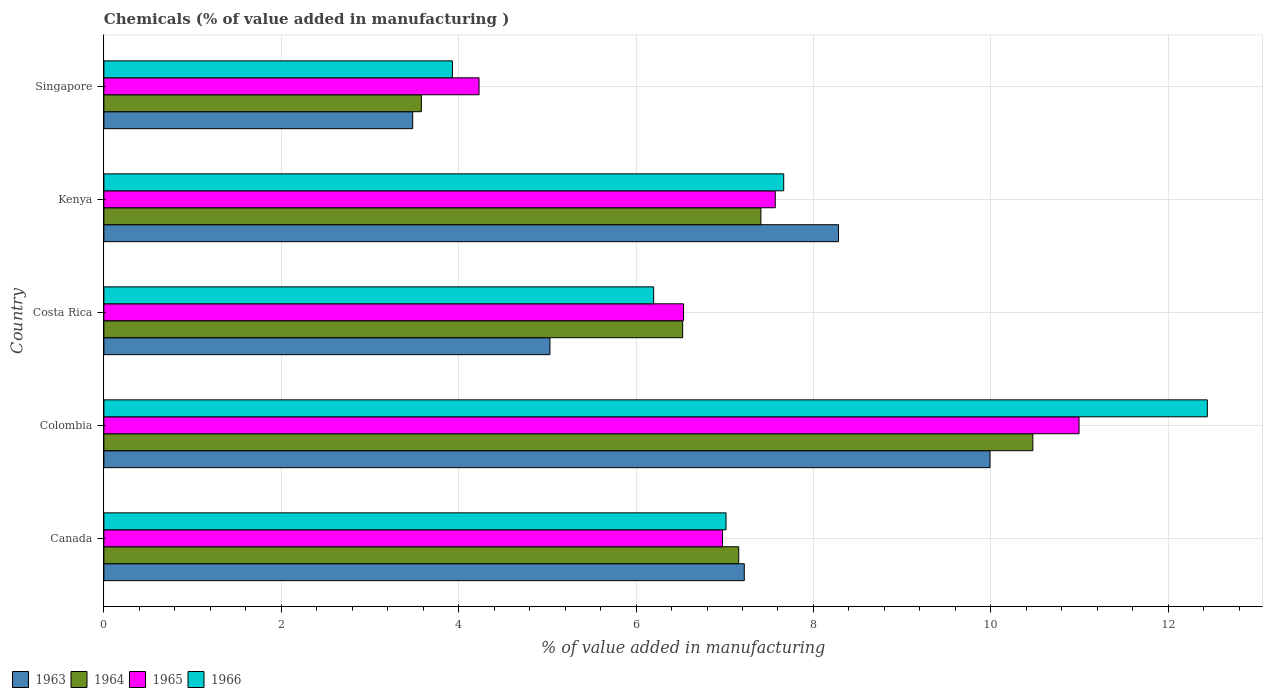How many different coloured bars are there?
Provide a succinct answer. 4. How many groups of bars are there?
Provide a succinct answer. 5. How many bars are there on the 1st tick from the top?
Make the answer very short. 4. How many bars are there on the 3rd tick from the bottom?
Provide a short and direct response. 4. What is the label of the 4th group of bars from the top?
Your answer should be very brief. Colombia. What is the value added in manufacturing chemicals in 1964 in Kenya?
Ensure brevity in your answer.  7.41. Across all countries, what is the maximum value added in manufacturing chemicals in 1965?
Your answer should be very brief. 10.99. Across all countries, what is the minimum value added in manufacturing chemicals in 1964?
Offer a terse response. 3.58. In which country was the value added in manufacturing chemicals in 1966 maximum?
Your answer should be very brief. Colombia. In which country was the value added in manufacturing chemicals in 1964 minimum?
Your answer should be very brief. Singapore. What is the total value added in manufacturing chemicals in 1966 in the graph?
Offer a terse response. 37.25. What is the difference between the value added in manufacturing chemicals in 1965 in Colombia and that in Costa Rica?
Ensure brevity in your answer.  4.46. What is the difference between the value added in manufacturing chemicals in 1965 in Costa Rica and the value added in manufacturing chemicals in 1966 in Singapore?
Provide a succinct answer. 2.61. What is the average value added in manufacturing chemicals in 1964 per country?
Make the answer very short. 7.03. What is the difference between the value added in manufacturing chemicals in 1965 and value added in manufacturing chemicals in 1966 in Kenya?
Offer a very short reply. -0.1. What is the ratio of the value added in manufacturing chemicals in 1966 in Colombia to that in Singapore?
Give a very brief answer. 3.17. What is the difference between the highest and the second highest value added in manufacturing chemicals in 1963?
Offer a very short reply. 1.71. What is the difference between the highest and the lowest value added in manufacturing chemicals in 1963?
Ensure brevity in your answer.  6.51. Is the sum of the value added in manufacturing chemicals in 1964 in Colombia and Singapore greater than the maximum value added in manufacturing chemicals in 1966 across all countries?
Your response must be concise. Yes. What does the 3rd bar from the top in Colombia represents?
Give a very brief answer. 1964. What does the 4th bar from the bottom in Colombia represents?
Provide a short and direct response. 1966. Is it the case that in every country, the sum of the value added in manufacturing chemicals in 1965 and value added in manufacturing chemicals in 1963 is greater than the value added in manufacturing chemicals in 1964?
Your answer should be compact. Yes. What is the difference between two consecutive major ticks on the X-axis?
Ensure brevity in your answer.  2. Are the values on the major ticks of X-axis written in scientific E-notation?
Your answer should be very brief. No. Does the graph contain grids?
Offer a very short reply. Yes. Where does the legend appear in the graph?
Give a very brief answer. Bottom left. How are the legend labels stacked?
Make the answer very short. Horizontal. What is the title of the graph?
Provide a short and direct response. Chemicals (% of value added in manufacturing ). What is the label or title of the X-axis?
Offer a very short reply. % of value added in manufacturing. What is the label or title of the Y-axis?
Offer a very short reply. Country. What is the % of value added in manufacturing of 1963 in Canada?
Provide a short and direct response. 7.22. What is the % of value added in manufacturing in 1964 in Canada?
Keep it short and to the point. 7.16. What is the % of value added in manufacturing in 1965 in Canada?
Offer a terse response. 6.98. What is the % of value added in manufacturing in 1966 in Canada?
Ensure brevity in your answer.  7.01. What is the % of value added in manufacturing in 1963 in Colombia?
Provide a short and direct response. 9.99. What is the % of value added in manufacturing of 1964 in Colombia?
Provide a succinct answer. 10.47. What is the % of value added in manufacturing in 1965 in Colombia?
Offer a terse response. 10.99. What is the % of value added in manufacturing of 1966 in Colombia?
Your answer should be compact. 12.44. What is the % of value added in manufacturing of 1963 in Costa Rica?
Keep it short and to the point. 5.03. What is the % of value added in manufacturing of 1964 in Costa Rica?
Make the answer very short. 6.53. What is the % of value added in manufacturing of 1965 in Costa Rica?
Offer a terse response. 6.54. What is the % of value added in manufacturing of 1966 in Costa Rica?
Ensure brevity in your answer.  6.2. What is the % of value added in manufacturing of 1963 in Kenya?
Your answer should be compact. 8.28. What is the % of value added in manufacturing in 1964 in Kenya?
Provide a succinct answer. 7.41. What is the % of value added in manufacturing in 1965 in Kenya?
Your answer should be compact. 7.57. What is the % of value added in manufacturing in 1966 in Kenya?
Provide a succinct answer. 7.67. What is the % of value added in manufacturing in 1963 in Singapore?
Keep it short and to the point. 3.48. What is the % of value added in manufacturing of 1964 in Singapore?
Provide a succinct answer. 3.58. What is the % of value added in manufacturing of 1965 in Singapore?
Offer a terse response. 4.23. What is the % of value added in manufacturing in 1966 in Singapore?
Your answer should be compact. 3.93. Across all countries, what is the maximum % of value added in manufacturing in 1963?
Your response must be concise. 9.99. Across all countries, what is the maximum % of value added in manufacturing of 1964?
Provide a short and direct response. 10.47. Across all countries, what is the maximum % of value added in manufacturing in 1965?
Your answer should be compact. 10.99. Across all countries, what is the maximum % of value added in manufacturing of 1966?
Keep it short and to the point. 12.44. Across all countries, what is the minimum % of value added in manufacturing of 1963?
Your answer should be compact. 3.48. Across all countries, what is the minimum % of value added in manufacturing of 1964?
Offer a very short reply. 3.58. Across all countries, what is the minimum % of value added in manufacturing of 1965?
Your answer should be compact. 4.23. Across all countries, what is the minimum % of value added in manufacturing in 1966?
Your answer should be compact. 3.93. What is the total % of value added in manufacturing in 1963 in the graph?
Ensure brevity in your answer.  34.01. What is the total % of value added in manufacturing of 1964 in the graph?
Provide a short and direct response. 35.15. What is the total % of value added in manufacturing of 1965 in the graph?
Offer a very short reply. 36.31. What is the total % of value added in manufacturing in 1966 in the graph?
Your response must be concise. 37.25. What is the difference between the % of value added in manufacturing in 1963 in Canada and that in Colombia?
Your answer should be compact. -2.77. What is the difference between the % of value added in manufacturing of 1964 in Canada and that in Colombia?
Give a very brief answer. -3.32. What is the difference between the % of value added in manufacturing of 1965 in Canada and that in Colombia?
Provide a short and direct response. -4.02. What is the difference between the % of value added in manufacturing of 1966 in Canada and that in Colombia?
Ensure brevity in your answer.  -5.43. What is the difference between the % of value added in manufacturing of 1963 in Canada and that in Costa Rica?
Your answer should be very brief. 2.19. What is the difference between the % of value added in manufacturing of 1964 in Canada and that in Costa Rica?
Provide a short and direct response. 0.63. What is the difference between the % of value added in manufacturing of 1965 in Canada and that in Costa Rica?
Provide a succinct answer. 0.44. What is the difference between the % of value added in manufacturing of 1966 in Canada and that in Costa Rica?
Provide a short and direct response. 0.82. What is the difference between the % of value added in manufacturing in 1963 in Canada and that in Kenya?
Your answer should be very brief. -1.06. What is the difference between the % of value added in manufacturing of 1964 in Canada and that in Kenya?
Keep it short and to the point. -0.25. What is the difference between the % of value added in manufacturing of 1965 in Canada and that in Kenya?
Your answer should be compact. -0.59. What is the difference between the % of value added in manufacturing of 1966 in Canada and that in Kenya?
Provide a short and direct response. -0.65. What is the difference between the % of value added in manufacturing in 1963 in Canada and that in Singapore?
Your answer should be very brief. 3.74. What is the difference between the % of value added in manufacturing in 1964 in Canada and that in Singapore?
Provide a succinct answer. 3.58. What is the difference between the % of value added in manufacturing in 1965 in Canada and that in Singapore?
Ensure brevity in your answer.  2.75. What is the difference between the % of value added in manufacturing of 1966 in Canada and that in Singapore?
Ensure brevity in your answer.  3.08. What is the difference between the % of value added in manufacturing in 1963 in Colombia and that in Costa Rica?
Offer a very short reply. 4.96. What is the difference between the % of value added in manufacturing of 1964 in Colombia and that in Costa Rica?
Keep it short and to the point. 3.95. What is the difference between the % of value added in manufacturing of 1965 in Colombia and that in Costa Rica?
Give a very brief answer. 4.46. What is the difference between the % of value added in manufacturing in 1966 in Colombia and that in Costa Rica?
Keep it short and to the point. 6.24. What is the difference between the % of value added in manufacturing in 1963 in Colombia and that in Kenya?
Provide a succinct answer. 1.71. What is the difference between the % of value added in manufacturing in 1964 in Colombia and that in Kenya?
Your response must be concise. 3.07. What is the difference between the % of value added in manufacturing of 1965 in Colombia and that in Kenya?
Offer a terse response. 3.43. What is the difference between the % of value added in manufacturing in 1966 in Colombia and that in Kenya?
Give a very brief answer. 4.78. What is the difference between the % of value added in manufacturing in 1963 in Colombia and that in Singapore?
Your response must be concise. 6.51. What is the difference between the % of value added in manufacturing of 1964 in Colombia and that in Singapore?
Provide a succinct answer. 6.89. What is the difference between the % of value added in manufacturing in 1965 in Colombia and that in Singapore?
Provide a short and direct response. 6.76. What is the difference between the % of value added in manufacturing in 1966 in Colombia and that in Singapore?
Give a very brief answer. 8.51. What is the difference between the % of value added in manufacturing of 1963 in Costa Rica and that in Kenya?
Your answer should be very brief. -3.25. What is the difference between the % of value added in manufacturing of 1964 in Costa Rica and that in Kenya?
Your answer should be very brief. -0.88. What is the difference between the % of value added in manufacturing of 1965 in Costa Rica and that in Kenya?
Ensure brevity in your answer.  -1.03. What is the difference between the % of value added in manufacturing of 1966 in Costa Rica and that in Kenya?
Offer a terse response. -1.47. What is the difference between the % of value added in manufacturing in 1963 in Costa Rica and that in Singapore?
Provide a succinct answer. 1.55. What is the difference between the % of value added in manufacturing of 1964 in Costa Rica and that in Singapore?
Provide a short and direct response. 2.95. What is the difference between the % of value added in manufacturing of 1965 in Costa Rica and that in Singapore?
Provide a short and direct response. 2.31. What is the difference between the % of value added in manufacturing of 1966 in Costa Rica and that in Singapore?
Offer a very short reply. 2.27. What is the difference between the % of value added in manufacturing in 1963 in Kenya and that in Singapore?
Your response must be concise. 4.8. What is the difference between the % of value added in manufacturing in 1964 in Kenya and that in Singapore?
Your answer should be very brief. 3.83. What is the difference between the % of value added in manufacturing of 1965 in Kenya and that in Singapore?
Your answer should be very brief. 3.34. What is the difference between the % of value added in manufacturing in 1966 in Kenya and that in Singapore?
Offer a very short reply. 3.74. What is the difference between the % of value added in manufacturing in 1963 in Canada and the % of value added in manufacturing in 1964 in Colombia?
Provide a succinct answer. -3.25. What is the difference between the % of value added in manufacturing in 1963 in Canada and the % of value added in manufacturing in 1965 in Colombia?
Provide a short and direct response. -3.77. What is the difference between the % of value added in manufacturing in 1963 in Canada and the % of value added in manufacturing in 1966 in Colombia?
Your answer should be very brief. -5.22. What is the difference between the % of value added in manufacturing of 1964 in Canada and the % of value added in manufacturing of 1965 in Colombia?
Offer a very short reply. -3.84. What is the difference between the % of value added in manufacturing in 1964 in Canada and the % of value added in manufacturing in 1966 in Colombia?
Your answer should be very brief. -5.28. What is the difference between the % of value added in manufacturing of 1965 in Canada and the % of value added in manufacturing of 1966 in Colombia?
Your answer should be compact. -5.47. What is the difference between the % of value added in manufacturing in 1963 in Canada and the % of value added in manufacturing in 1964 in Costa Rica?
Give a very brief answer. 0.69. What is the difference between the % of value added in manufacturing of 1963 in Canada and the % of value added in manufacturing of 1965 in Costa Rica?
Your answer should be very brief. 0.68. What is the difference between the % of value added in manufacturing of 1963 in Canada and the % of value added in manufacturing of 1966 in Costa Rica?
Offer a very short reply. 1.02. What is the difference between the % of value added in manufacturing in 1964 in Canada and the % of value added in manufacturing in 1965 in Costa Rica?
Your answer should be very brief. 0.62. What is the difference between the % of value added in manufacturing in 1964 in Canada and the % of value added in manufacturing in 1966 in Costa Rica?
Your response must be concise. 0.96. What is the difference between the % of value added in manufacturing in 1965 in Canada and the % of value added in manufacturing in 1966 in Costa Rica?
Your answer should be compact. 0.78. What is the difference between the % of value added in manufacturing in 1963 in Canada and the % of value added in manufacturing in 1964 in Kenya?
Keep it short and to the point. -0.19. What is the difference between the % of value added in manufacturing in 1963 in Canada and the % of value added in manufacturing in 1965 in Kenya?
Provide a short and direct response. -0.35. What is the difference between the % of value added in manufacturing of 1963 in Canada and the % of value added in manufacturing of 1966 in Kenya?
Your answer should be very brief. -0.44. What is the difference between the % of value added in manufacturing in 1964 in Canada and the % of value added in manufacturing in 1965 in Kenya?
Your answer should be very brief. -0.41. What is the difference between the % of value added in manufacturing of 1964 in Canada and the % of value added in manufacturing of 1966 in Kenya?
Keep it short and to the point. -0.51. What is the difference between the % of value added in manufacturing in 1965 in Canada and the % of value added in manufacturing in 1966 in Kenya?
Offer a terse response. -0.69. What is the difference between the % of value added in manufacturing in 1963 in Canada and the % of value added in manufacturing in 1964 in Singapore?
Provide a succinct answer. 3.64. What is the difference between the % of value added in manufacturing in 1963 in Canada and the % of value added in manufacturing in 1965 in Singapore?
Keep it short and to the point. 2.99. What is the difference between the % of value added in manufacturing in 1963 in Canada and the % of value added in manufacturing in 1966 in Singapore?
Keep it short and to the point. 3.29. What is the difference between the % of value added in manufacturing in 1964 in Canada and the % of value added in manufacturing in 1965 in Singapore?
Your answer should be compact. 2.93. What is the difference between the % of value added in manufacturing of 1964 in Canada and the % of value added in manufacturing of 1966 in Singapore?
Your response must be concise. 3.23. What is the difference between the % of value added in manufacturing of 1965 in Canada and the % of value added in manufacturing of 1966 in Singapore?
Offer a terse response. 3.05. What is the difference between the % of value added in manufacturing of 1963 in Colombia and the % of value added in manufacturing of 1964 in Costa Rica?
Your answer should be compact. 3.47. What is the difference between the % of value added in manufacturing of 1963 in Colombia and the % of value added in manufacturing of 1965 in Costa Rica?
Your answer should be very brief. 3.46. What is the difference between the % of value added in manufacturing of 1963 in Colombia and the % of value added in manufacturing of 1966 in Costa Rica?
Make the answer very short. 3.79. What is the difference between the % of value added in manufacturing in 1964 in Colombia and the % of value added in manufacturing in 1965 in Costa Rica?
Your answer should be very brief. 3.94. What is the difference between the % of value added in manufacturing of 1964 in Colombia and the % of value added in manufacturing of 1966 in Costa Rica?
Ensure brevity in your answer.  4.28. What is the difference between the % of value added in manufacturing of 1965 in Colombia and the % of value added in manufacturing of 1966 in Costa Rica?
Offer a terse response. 4.8. What is the difference between the % of value added in manufacturing in 1963 in Colombia and the % of value added in manufacturing in 1964 in Kenya?
Give a very brief answer. 2.58. What is the difference between the % of value added in manufacturing in 1963 in Colombia and the % of value added in manufacturing in 1965 in Kenya?
Offer a terse response. 2.42. What is the difference between the % of value added in manufacturing in 1963 in Colombia and the % of value added in manufacturing in 1966 in Kenya?
Offer a very short reply. 2.33. What is the difference between the % of value added in manufacturing of 1964 in Colombia and the % of value added in manufacturing of 1965 in Kenya?
Your answer should be very brief. 2.9. What is the difference between the % of value added in manufacturing in 1964 in Colombia and the % of value added in manufacturing in 1966 in Kenya?
Offer a very short reply. 2.81. What is the difference between the % of value added in manufacturing in 1965 in Colombia and the % of value added in manufacturing in 1966 in Kenya?
Your response must be concise. 3.33. What is the difference between the % of value added in manufacturing of 1963 in Colombia and the % of value added in manufacturing of 1964 in Singapore?
Your answer should be compact. 6.41. What is the difference between the % of value added in manufacturing of 1963 in Colombia and the % of value added in manufacturing of 1965 in Singapore?
Offer a terse response. 5.76. What is the difference between the % of value added in manufacturing in 1963 in Colombia and the % of value added in manufacturing in 1966 in Singapore?
Offer a terse response. 6.06. What is the difference between the % of value added in manufacturing in 1964 in Colombia and the % of value added in manufacturing in 1965 in Singapore?
Keep it short and to the point. 6.24. What is the difference between the % of value added in manufacturing in 1964 in Colombia and the % of value added in manufacturing in 1966 in Singapore?
Keep it short and to the point. 6.54. What is the difference between the % of value added in manufacturing of 1965 in Colombia and the % of value added in manufacturing of 1966 in Singapore?
Offer a very short reply. 7.07. What is the difference between the % of value added in manufacturing in 1963 in Costa Rica and the % of value added in manufacturing in 1964 in Kenya?
Give a very brief answer. -2.38. What is the difference between the % of value added in manufacturing in 1963 in Costa Rica and the % of value added in manufacturing in 1965 in Kenya?
Provide a short and direct response. -2.54. What is the difference between the % of value added in manufacturing in 1963 in Costa Rica and the % of value added in manufacturing in 1966 in Kenya?
Keep it short and to the point. -2.64. What is the difference between the % of value added in manufacturing in 1964 in Costa Rica and the % of value added in manufacturing in 1965 in Kenya?
Your response must be concise. -1.04. What is the difference between the % of value added in manufacturing in 1964 in Costa Rica and the % of value added in manufacturing in 1966 in Kenya?
Make the answer very short. -1.14. What is the difference between the % of value added in manufacturing of 1965 in Costa Rica and the % of value added in manufacturing of 1966 in Kenya?
Provide a succinct answer. -1.13. What is the difference between the % of value added in manufacturing of 1963 in Costa Rica and the % of value added in manufacturing of 1964 in Singapore?
Make the answer very short. 1.45. What is the difference between the % of value added in manufacturing of 1963 in Costa Rica and the % of value added in manufacturing of 1965 in Singapore?
Ensure brevity in your answer.  0.8. What is the difference between the % of value added in manufacturing of 1963 in Costa Rica and the % of value added in manufacturing of 1966 in Singapore?
Keep it short and to the point. 1.1. What is the difference between the % of value added in manufacturing in 1964 in Costa Rica and the % of value added in manufacturing in 1965 in Singapore?
Provide a succinct answer. 2.3. What is the difference between the % of value added in manufacturing in 1964 in Costa Rica and the % of value added in manufacturing in 1966 in Singapore?
Give a very brief answer. 2.6. What is the difference between the % of value added in manufacturing of 1965 in Costa Rica and the % of value added in manufacturing of 1966 in Singapore?
Give a very brief answer. 2.61. What is the difference between the % of value added in manufacturing in 1963 in Kenya and the % of value added in manufacturing in 1964 in Singapore?
Your answer should be very brief. 4.7. What is the difference between the % of value added in manufacturing in 1963 in Kenya and the % of value added in manufacturing in 1965 in Singapore?
Your answer should be very brief. 4.05. What is the difference between the % of value added in manufacturing in 1963 in Kenya and the % of value added in manufacturing in 1966 in Singapore?
Keep it short and to the point. 4.35. What is the difference between the % of value added in manufacturing in 1964 in Kenya and the % of value added in manufacturing in 1965 in Singapore?
Your answer should be very brief. 3.18. What is the difference between the % of value added in manufacturing in 1964 in Kenya and the % of value added in manufacturing in 1966 in Singapore?
Provide a succinct answer. 3.48. What is the difference between the % of value added in manufacturing in 1965 in Kenya and the % of value added in manufacturing in 1966 in Singapore?
Offer a terse response. 3.64. What is the average % of value added in manufacturing of 1963 per country?
Keep it short and to the point. 6.8. What is the average % of value added in manufacturing in 1964 per country?
Offer a terse response. 7.03. What is the average % of value added in manufacturing in 1965 per country?
Your response must be concise. 7.26. What is the average % of value added in manufacturing of 1966 per country?
Ensure brevity in your answer.  7.45. What is the difference between the % of value added in manufacturing of 1963 and % of value added in manufacturing of 1964 in Canada?
Your answer should be very brief. 0.06. What is the difference between the % of value added in manufacturing in 1963 and % of value added in manufacturing in 1965 in Canada?
Your answer should be very brief. 0.25. What is the difference between the % of value added in manufacturing of 1963 and % of value added in manufacturing of 1966 in Canada?
Provide a short and direct response. 0.21. What is the difference between the % of value added in manufacturing in 1964 and % of value added in manufacturing in 1965 in Canada?
Your answer should be very brief. 0.18. What is the difference between the % of value added in manufacturing of 1964 and % of value added in manufacturing of 1966 in Canada?
Keep it short and to the point. 0.14. What is the difference between the % of value added in manufacturing in 1965 and % of value added in manufacturing in 1966 in Canada?
Your answer should be very brief. -0.04. What is the difference between the % of value added in manufacturing in 1963 and % of value added in manufacturing in 1964 in Colombia?
Your answer should be compact. -0.48. What is the difference between the % of value added in manufacturing of 1963 and % of value added in manufacturing of 1965 in Colombia?
Keep it short and to the point. -1. What is the difference between the % of value added in manufacturing in 1963 and % of value added in manufacturing in 1966 in Colombia?
Make the answer very short. -2.45. What is the difference between the % of value added in manufacturing in 1964 and % of value added in manufacturing in 1965 in Colombia?
Give a very brief answer. -0.52. What is the difference between the % of value added in manufacturing in 1964 and % of value added in manufacturing in 1966 in Colombia?
Your answer should be compact. -1.97. What is the difference between the % of value added in manufacturing of 1965 and % of value added in manufacturing of 1966 in Colombia?
Your response must be concise. -1.45. What is the difference between the % of value added in manufacturing in 1963 and % of value added in manufacturing in 1964 in Costa Rica?
Make the answer very short. -1.5. What is the difference between the % of value added in manufacturing of 1963 and % of value added in manufacturing of 1965 in Costa Rica?
Your answer should be compact. -1.51. What is the difference between the % of value added in manufacturing in 1963 and % of value added in manufacturing in 1966 in Costa Rica?
Your answer should be very brief. -1.17. What is the difference between the % of value added in manufacturing of 1964 and % of value added in manufacturing of 1965 in Costa Rica?
Your answer should be very brief. -0.01. What is the difference between the % of value added in manufacturing in 1964 and % of value added in manufacturing in 1966 in Costa Rica?
Provide a short and direct response. 0.33. What is the difference between the % of value added in manufacturing in 1965 and % of value added in manufacturing in 1966 in Costa Rica?
Offer a very short reply. 0.34. What is the difference between the % of value added in manufacturing in 1963 and % of value added in manufacturing in 1964 in Kenya?
Give a very brief answer. 0.87. What is the difference between the % of value added in manufacturing in 1963 and % of value added in manufacturing in 1965 in Kenya?
Keep it short and to the point. 0.71. What is the difference between the % of value added in manufacturing in 1963 and % of value added in manufacturing in 1966 in Kenya?
Keep it short and to the point. 0.62. What is the difference between the % of value added in manufacturing in 1964 and % of value added in manufacturing in 1965 in Kenya?
Provide a succinct answer. -0.16. What is the difference between the % of value added in manufacturing in 1964 and % of value added in manufacturing in 1966 in Kenya?
Your answer should be very brief. -0.26. What is the difference between the % of value added in manufacturing in 1965 and % of value added in manufacturing in 1966 in Kenya?
Offer a very short reply. -0.1. What is the difference between the % of value added in manufacturing of 1963 and % of value added in manufacturing of 1964 in Singapore?
Give a very brief answer. -0.1. What is the difference between the % of value added in manufacturing in 1963 and % of value added in manufacturing in 1965 in Singapore?
Keep it short and to the point. -0.75. What is the difference between the % of value added in manufacturing in 1963 and % of value added in manufacturing in 1966 in Singapore?
Provide a succinct answer. -0.45. What is the difference between the % of value added in manufacturing of 1964 and % of value added in manufacturing of 1965 in Singapore?
Your response must be concise. -0.65. What is the difference between the % of value added in manufacturing of 1964 and % of value added in manufacturing of 1966 in Singapore?
Keep it short and to the point. -0.35. What is the difference between the % of value added in manufacturing of 1965 and % of value added in manufacturing of 1966 in Singapore?
Your answer should be very brief. 0.3. What is the ratio of the % of value added in manufacturing in 1963 in Canada to that in Colombia?
Your answer should be compact. 0.72. What is the ratio of the % of value added in manufacturing of 1964 in Canada to that in Colombia?
Provide a succinct answer. 0.68. What is the ratio of the % of value added in manufacturing in 1965 in Canada to that in Colombia?
Your answer should be very brief. 0.63. What is the ratio of the % of value added in manufacturing in 1966 in Canada to that in Colombia?
Your answer should be compact. 0.56. What is the ratio of the % of value added in manufacturing in 1963 in Canada to that in Costa Rica?
Provide a short and direct response. 1.44. What is the ratio of the % of value added in manufacturing of 1964 in Canada to that in Costa Rica?
Provide a short and direct response. 1.1. What is the ratio of the % of value added in manufacturing of 1965 in Canada to that in Costa Rica?
Offer a very short reply. 1.07. What is the ratio of the % of value added in manufacturing of 1966 in Canada to that in Costa Rica?
Offer a very short reply. 1.13. What is the ratio of the % of value added in manufacturing in 1963 in Canada to that in Kenya?
Your response must be concise. 0.87. What is the ratio of the % of value added in manufacturing of 1964 in Canada to that in Kenya?
Provide a succinct answer. 0.97. What is the ratio of the % of value added in manufacturing of 1965 in Canada to that in Kenya?
Your answer should be very brief. 0.92. What is the ratio of the % of value added in manufacturing of 1966 in Canada to that in Kenya?
Provide a succinct answer. 0.92. What is the ratio of the % of value added in manufacturing in 1963 in Canada to that in Singapore?
Offer a terse response. 2.07. What is the ratio of the % of value added in manufacturing of 1964 in Canada to that in Singapore?
Your response must be concise. 2. What is the ratio of the % of value added in manufacturing of 1965 in Canada to that in Singapore?
Make the answer very short. 1.65. What is the ratio of the % of value added in manufacturing of 1966 in Canada to that in Singapore?
Provide a short and direct response. 1.78. What is the ratio of the % of value added in manufacturing of 1963 in Colombia to that in Costa Rica?
Offer a very short reply. 1.99. What is the ratio of the % of value added in manufacturing in 1964 in Colombia to that in Costa Rica?
Provide a short and direct response. 1.61. What is the ratio of the % of value added in manufacturing in 1965 in Colombia to that in Costa Rica?
Give a very brief answer. 1.68. What is the ratio of the % of value added in manufacturing of 1966 in Colombia to that in Costa Rica?
Give a very brief answer. 2.01. What is the ratio of the % of value added in manufacturing of 1963 in Colombia to that in Kenya?
Your response must be concise. 1.21. What is the ratio of the % of value added in manufacturing in 1964 in Colombia to that in Kenya?
Offer a very short reply. 1.41. What is the ratio of the % of value added in manufacturing in 1965 in Colombia to that in Kenya?
Your answer should be very brief. 1.45. What is the ratio of the % of value added in manufacturing in 1966 in Colombia to that in Kenya?
Ensure brevity in your answer.  1.62. What is the ratio of the % of value added in manufacturing in 1963 in Colombia to that in Singapore?
Offer a terse response. 2.87. What is the ratio of the % of value added in manufacturing in 1964 in Colombia to that in Singapore?
Provide a short and direct response. 2.93. What is the ratio of the % of value added in manufacturing in 1965 in Colombia to that in Singapore?
Your response must be concise. 2.6. What is the ratio of the % of value added in manufacturing of 1966 in Colombia to that in Singapore?
Provide a short and direct response. 3.17. What is the ratio of the % of value added in manufacturing in 1963 in Costa Rica to that in Kenya?
Offer a very short reply. 0.61. What is the ratio of the % of value added in manufacturing in 1964 in Costa Rica to that in Kenya?
Give a very brief answer. 0.88. What is the ratio of the % of value added in manufacturing in 1965 in Costa Rica to that in Kenya?
Keep it short and to the point. 0.86. What is the ratio of the % of value added in manufacturing in 1966 in Costa Rica to that in Kenya?
Your response must be concise. 0.81. What is the ratio of the % of value added in manufacturing in 1963 in Costa Rica to that in Singapore?
Provide a succinct answer. 1.44. What is the ratio of the % of value added in manufacturing in 1964 in Costa Rica to that in Singapore?
Your answer should be compact. 1.82. What is the ratio of the % of value added in manufacturing of 1965 in Costa Rica to that in Singapore?
Provide a succinct answer. 1.55. What is the ratio of the % of value added in manufacturing of 1966 in Costa Rica to that in Singapore?
Your answer should be compact. 1.58. What is the ratio of the % of value added in manufacturing of 1963 in Kenya to that in Singapore?
Your answer should be compact. 2.38. What is the ratio of the % of value added in manufacturing in 1964 in Kenya to that in Singapore?
Make the answer very short. 2.07. What is the ratio of the % of value added in manufacturing in 1965 in Kenya to that in Singapore?
Ensure brevity in your answer.  1.79. What is the ratio of the % of value added in manufacturing of 1966 in Kenya to that in Singapore?
Keep it short and to the point. 1.95. What is the difference between the highest and the second highest % of value added in manufacturing in 1963?
Give a very brief answer. 1.71. What is the difference between the highest and the second highest % of value added in manufacturing of 1964?
Your answer should be very brief. 3.07. What is the difference between the highest and the second highest % of value added in manufacturing of 1965?
Provide a short and direct response. 3.43. What is the difference between the highest and the second highest % of value added in manufacturing of 1966?
Give a very brief answer. 4.78. What is the difference between the highest and the lowest % of value added in manufacturing in 1963?
Make the answer very short. 6.51. What is the difference between the highest and the lowest % of value added in manufacturing in 1964?
Make the answer very short. 6.89. What is the difference between the highest and the lowest % of value added in manufacturing of 1965?
Give a very brief answer. 6.76. What is the difference between the highest and the lowest % of value added in manufacturing in 1966?
Provide a short and direct response. 8.51. 